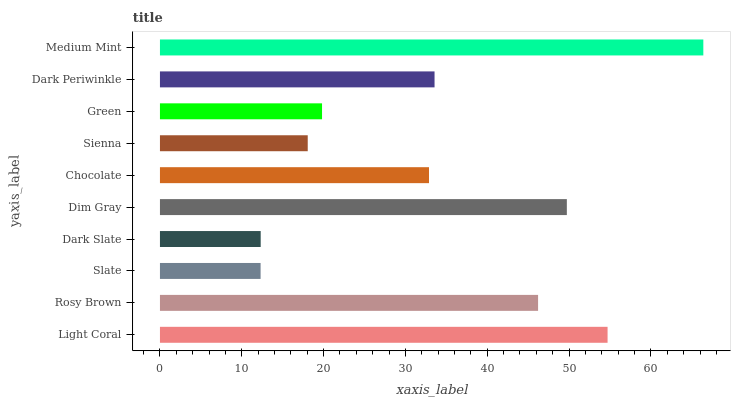Is Slate the minimum?
Answer yes or no. Yes. Is Medium Mint the maximum?
Answer yes or no. Yes. Is Rosy Brown the minimum?
Answer yes or no. No. Is Rosy Brown the maximum?
Answer yes or no. No. Is Light Coral greater than Rosy Brown?
Answer yes or no. Yes. Is Rosy Brown less than Light Coral?
Answer yes or no. Yes. Is Rosy Brown greater than Light Coral?
Answer yes or no. No. Is Light Coral less than Rosy Brown?
Answer yes or no. No. Is Dark Periwinkle the high median?
Answer yes or no. Yes. Is Chocolate the low median?
Answer yes or no. Yes. Is Medium Mint the high median?
Answer yes or no. No. Is Rosy Brown the low median?
Answer yes or no. No. 